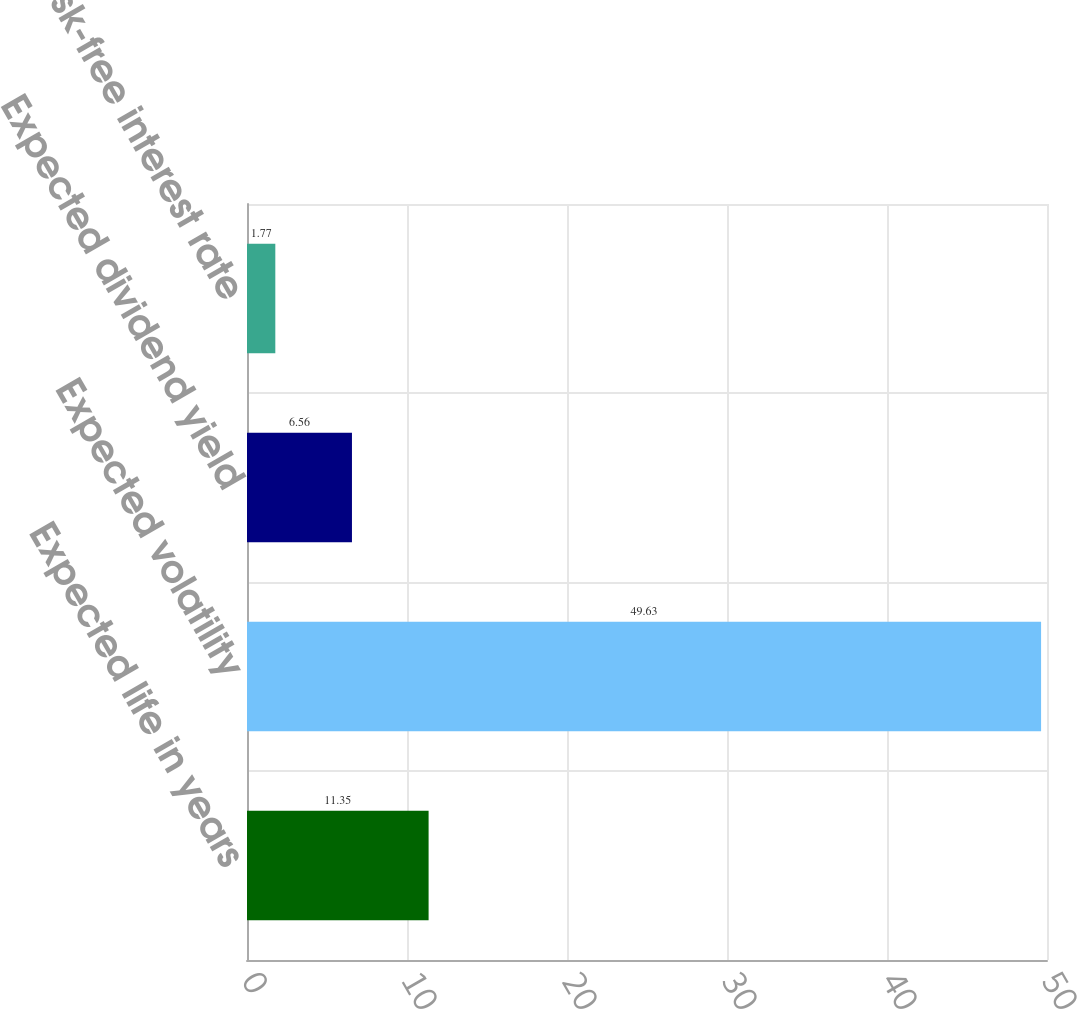<chart> <loc_0><loc_0><loc_500><loc_500><bar_chart><fcel>Expected life in years<fcel>Expected volatility<fcel>Expected dividend yield<fcel>Risk-free interest rate<nl><fcel>11.35<fcel>49.63<fcel>6.56<fcel>1.77<nl></chart> 